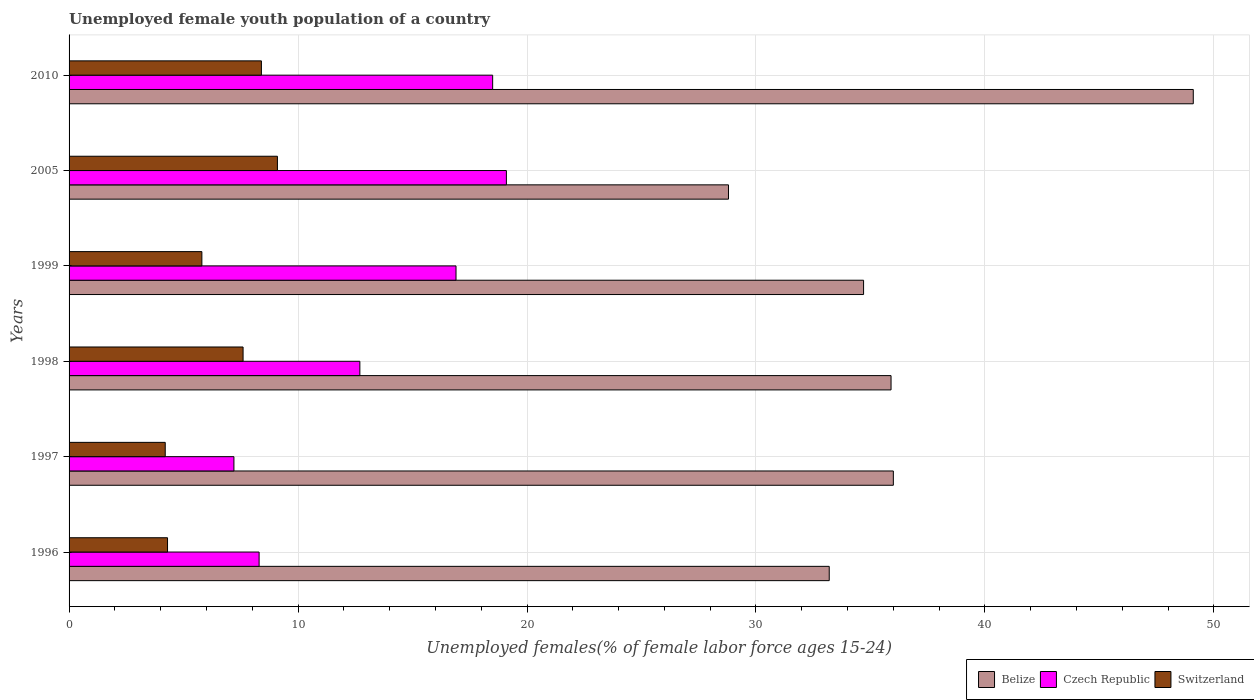How many different coloured bars are there?
Your response must be concise. 3. Are the number of bars per tick equal to the number of legend labels?
Give a very brief answer. Yes. How many bars are there on the 4th tick from the top?
Ensure brevity in your answer.  3. How many bars are there on the 3rd tick from the bottom?
Offer a very short reply. 3. What is the label of the 6th group of bars from the top?
Ensure brevity in your answer.  1996. In how many cases, is the number of bars for a given year not equal to the number of legend labels?
Offer a terse response. 0. What is the percentage of unemployed female youth population in Switzerland in 1999?
Offer a terse response. 5.8. Across all years, what is the maximum percentage of unemployed female youth population in Czech Republic?
Give a very brief answer. 19.1. Across all years, what is the minimum percentage of unemployed female youth population in Czech Republic?
Your response must be concise. 7.2. What is the total percentage of unemployed female youth population in Czech Republic in the graph?
Give a very brief answer. 82.7. What is the difference between the percentage of unemployed female youth population in Switzerland in 1996 and that in 1998?
Provide a short and direct response. -3.3. What is the difference between the percentage of unemployed female youth population in Czech Republic in 2005 and the percentage of unemployed female youth population in Belize in 1999?
Your answer should be compact. -15.6. What is the average percentage of unemployed female youth population in Switzerland per year?
Give a very brief answer. 6.57. In the year 2010, what is the difference between the percentage of unemployed female youth population in Belize and percentage of unemployed female youth population in Czech Republic?
Give a very brief answer. 30.6. What is the ratio of the percentage of unemployed female youth population in Belize in 1999 to that in 2005?
Your answer should be very brief. 1.2. What is the difference between the highest and the second highest percentage of unemployed female youth population in Belize?
Keep it short and to the point. 13.1. What is the difference between the highest and the lowest percentage of unemployed female youth population in Belize?
Ensure brevity in your answer.  20.3. What does the 3rd bar from the top in 2005 represents?
Offer a terse response. Belize. What does the 3rd bar from the bottom in 2005 represents?
Your answer should be compact. Switzerland. Is it the case that in every year, the sum of the percentage of unemployed female youth population in Switzerland and percentage of unemployed female youth population in Belize is greater than the percentage of unemployed female youth population in Czech Republic?
Give a very brief answer. Yes. Are all the bars in the graph horizontal?
Ensure brevity in your answer.  Yes. How many years are there in the graph?
Offer a very short reply. 6. Are the values on the major ticks of X-axis written in scientific E-notation?
Your answer should be very brief. No. Does the graph contain any zero values?
Your response must be concise. No. Does the graph contain grids?
Your response must be concise. Yes. Where does the legend appear in the graph?
Keep it short and to the point. Bottom right. How many legend labels are there?
Offer a terse response. 3. What is the title of the graph?
Ensure brevity in your answer.  Unemployed female youth population of a country. Does "Lao PDR" appear as one of the legend labels in the graph?
Offer a very short reply. No. What is the label or title of the X-axis?
Keep it short and to the point. Unemployed females(% of female labor force ages 15-24). What is the Unemployed females(% of female labor force ages 15-24) in Belize in 1996?
Ensure brevity in your answer.  33.2. What is the Unemployed females(% of female labor force ages 15-24) in Czech Republic in 1996?
Ensure brevity in your answer.  8.3. What is the Unemployed females(% of female labor force ages 15-24) in Switzerland in 1996?
Provide a succinct answer. 4.3. What is the Unemployed females(% of female labor force ages 15-24) of Belize in 1997?
Provide a succinct answer. 36. What is the Unemployed females(% of female labor force ages 15-24) of Czech Republic in 1997?
Your answer should be compact. 7.2. What is the Unemployed females(% of female labor force ages 15-24) in Switzerland in 1997?
Make the answer very short. 4.2. What is the Unemployed females(% of female labor force ages 15-24) in Belize in 1998?
Your response must be concise. 35.9. What is the Unemployed females(% of female labor force ages 15-24) of Czech Republic in 1998?
Your answer should be very brief. 12.7. What is the Unemployed females(% of female labor force ages 15-24) in Switzerland in 1998?
Your answer should be very brief. 7.6. What is the Unemployed females(% of female labor force ages 15-24) in Belize in 1999?
Your answer should be very brief. 34.7. What is the Unemployed females(% of female labor force ages 15-24) in Czech Republic in 1999?
Your response must be concise. 16.9. What is the Unemployed females(% of female labor force ages 15-24) of Switzerland in 1999?
Make the answer very short. 5.8. What is the Unemployed females(% of female labor force ages 15-24) of Belize in 2005?
Provide a short and direct response. 28.8. What is the Unemployed females(% of female labor force ages 15-24) in Czech Republic in 2005?
Your answer should be compact. 19.1. What is the Unemployed females(% of female labor force ages 15-24) of Switzerland in 2005?
Provide a short and direct response. 9.1. What is the Unemployed females(% of female labor force ages 15-24) of Belize in 2010?
Your response must be concise. 49.1. What is the Unemployed females(% of female labor force ages 15-24) in Switzerland in 2010?
Provide a succinct answer. 8.4. Across all years, what is the maximum Unemployed females(% of female labor force ages 15-24) of Belize?
Keep it short and to the point. 49.1. Across all years, what is the maximum Unemployed females(% of female labor force ages 15-24) of Czech Republic?
Your answer should be very brief. 19.1. Across all years, what is the maximum Unemployed females(% of female labor force ages 15-24) in Switzerland?
Give a very brief answer. 9.1. Across all years, what is the minimum Unemployed females(% of female labor force ages 15-24) in Belize?
Provide a succinct answer. 28.8. Across all years, what is the minimum Unemployed females(% of female labor force ages 15-24) of Czech Republic?
Offer a very short reply. 7.2. Across all years, what is the minimum Unemployed females(% of female labor force ages 15-24) in Switzerland?
Provide a short and direct response. 4.2. What is the total Unemployed females(% of female labor force ages 15-24) in Belize in the graph?
Offer a terse response. 217.7. What is the total Unemployed females(% of female labor force ages 15-24) in Czech Republic in the graph?
Your answer should be very brief. 82.7. What is the total Unemployed females(% of female labor force ages 15-24) of Switzerland in the graph?
Ensure brevity in your answer.  39.4. What is the difference between the Unemployed females(% of female labor force ages 15-24) in Belize in 1996 and that in 1997?
Provide a succinct answer. -2.8. What is the difference between the Unemployed females(% of female labor force ages 15-24) of Belize in 1996 and that in 1998?
Offer a very short reply. -2.7. What is the difference between the Unemployed females(% of female labor force ages 15-24) in Belize in 1996 and that in 1999?
Provide a succinct answer. -1.5. What is the difference between the Unemployed females(% of female labor force ages 15-24) of Switzerland in 1996 and that in 1999?
Your answer should be very brief. -1.5. What is the difference between the Unemployed females(% of female labor force ages 15-24) in Belize in 1996 and that in 2005?
Offer a very short reply. 4.4. What is the difference between the Unemployed females(% of female labor force ages 15-24) of Switzerland in 1996 and that in 2005?
Keep it short and to the point. -4.8. What is the difference between the Unemployed females(% of female labor force ages 15-24) of Belize in 1996 and that in 2010?
Give a very brief answer. -15.9. What is the difference between the Unemployed females(% of female labor force ages 15-24) of Switzerland in 1996 and that in 2010?
Give a very brief answer. -4.1. What is the difference between the Unemployed females(% of female labor force ages 15-24) in Switzerland in 1997 and that in 1998?
Your answer should be compact. -3.4. What is the difference between the Unemployed females(% of female labor force ages 15-24) in Belize in 1997 and that in 1999?
Offer a very short reply. 1.3. What is the difference between the Unemployed females(% of female labor force ages 15-24) in Czech Republic in 1997 and that in 1999?
Keep it short and to the point. -9.7. What is the difference between the Unemployed females(% of female labor force ages 15-24) of Czech Republic in 1997 and that in 2005?
Make the answer very short. -11.9. What is the difference between the Unemployed females(% of female labor force ages 15-24) in Czech Republic in 1997 and that in 2010?
Your answer should be very brief. -11.3. What is the difference between the Unemployed females(% of female labor force ages 15-24) in Switzerland in 1997 and that in 2010?
Offer a very short reply. -4.2. What is the difference between the Unemployed females(% of female labor force ages 15-24) in Czech Republic in 1998 and that in 1999?
Provide a succinct answer. -4.2. What is the difference between the Unemployed females(% of female labor force ages 15-24) of Belize in 1998 and that in 2005?
Your answer should be compact. 7.1. What is the difference between the Unemployed females(% of female labor force ages 15-24) of Czech Republic in 1998 and that in 2005?
Your response must be concise. -6.4. What is the difference between the Unemployed females(% of female labor force ages 15-24) in Belize in 1998 and that in 2010?
Ensure brevity in your answer.  -13.2. What is the difference between the Unemployed females(% of female labor force ages 15-24) of Czech Republic in 1998 and that in 2010?
Make the answer very short. -5.8. What is the difference between the Unemployed females(% of female labor force ages 15-24) in Czech Republic in 1999 and that in 2005?
Give a very brief answer. -2.2. What is the difference between the Unemployed females(% of female labor force ages 15-24) in Belize in 1999 and that in 2010?
Offer a very short reply. -14.4. What is the difference between the Unemployed females(% of female labor force ages 15-24) in Switzerland in 1999 and that in 2010?
Provide a short and direct response. -2.6. What is the difference between the Unemployed females(% of female labor force ages 15-24) of Belize in 2005 and that in 2010?
Your answer should be very brief. -20.3. What is the difference between the Unemployed females(% of female labor force ages 15-24) in Czech Republic in 2005 and that in 2010?
Provide a succinct answer. 0.6. What is the difference between the Unemployed females(% of female labor force ages 15-24) of Belize in 1996 and the Unemployed females(% of female labor force ages 15-24) of Czech Republic in 1997?
Provide a succinct answer. 26. What is the difference between the Unemployed females(% of female labor force ages 15-24) in Belize in 1996 and the Unemployed females(% of female labor force ages 15-24) in Switzerland in 1998?
Your answer should be compact. 25.6. What is the difference between the Unemployed females(% of female labor force ages 15-24) in Czech Republic in 1996 and the Unemployed females(% of female labor force ages 15-24) in Switzerland in 1998?
Keep it short and to the point. 0.7. What is the difference between the Unemployed females(% of female labor force ages 15-24) of Belize in 1996 and the Unemployed females(% of female labor force ages 15-24) of Czech Republic in 1999?
Offer a very short reply. 16.3. What is the difference between the Unemployed females(% of female labor force ages 15-24) of Belize in 1996 and the Unemployed females(% of female labor force ages 15-24) of Switzerland in 1999?
Provide a short and direct response. 27.4. What is the difference between the Unemployed females(% of female labor force ages 15-24) in Belize in 1996 and the Unemployed females(% of female labor force ages 15-24) in Switzerland in 2005?
Your answer should be compact. 24.1. What is the difference between the Unemployed females(% of female labor force ages 15-24) in Belize in 1996 and the Unemployed females(% of female labor force ages 15-24) in Czech Republic in 2010?
Give a very brief answer. 14.7. What is the difference between the Unemployed females(% of female labor force ages 15-24) of Belize in 1996 and the Unemployed females(% of female labor force ages 15-24) of Switzerland in 2010?
Your response must be concise. 24.8. What is the difference between the Unemployed females(% of female labor force ages 15-24) of Czech Republic in 1996 and the Unemployed females(% of female labor force ages 15-24) of Switzerland in 2010?
Keep it short and to the point. -0.1. What is the difference between the Unemployed females(% of female labor force ages 15-24) in Belize in 1997 and the Unemployed females(% of female labor force ages 15-24) in Czech Republic in 1998?
Provide a succinct answer. 23.3. What is the difference between the Unemployed females(% of female labor force ages 15-24) of Belize in 1997 and the Unemployed females(% of female labor force ages 15-24) of Switzerland in 1998?
Make the answer very short. 28.4. What is the difference between the Unemployed females(% of female labor force ages 15-24) in Belize in 1997 and the Unemployed females(% of female labor force ages 15-24) in Switzerland in 1999?
Keep it short and to the point. 30.2. What is the difference between the Unemployed females(% of female labor force ages 15-24) in Czech Republic in 1997 and the Unemployed females(% of female labor force ages 15-24) in Switzerland in 1999?
Provide a succinct answer. 1.4. What is the difference between the Unemployed females(% of female labor force ages 15-24) of Belize in 1997 and the Unemployed females(% of female labor force ages 15-24) of Czech Republic in 2005?
Offer a terse response. 16.9. What is the difference between the Unemployed females(% of female labor force ages 15-24) in Belize in 1997 and the Unemployed females(% of female labor force ages 15-24) in Switzerland in 2005?
Offer a terse response. 26.9. What is the difference between the Unemployed females(% of female labor force ages 15-24) of Belize in 1997 and the Unemployed females(% of female labor force ages 15-24) of Czech Republic in 2010?
Offer a terse response. 17.5. What is the difference between the Unemployed females(% of female labor force ages 15-24) of Belize in 1997 and the Unemployed females(% of female labor force ages 15-24) of Switzerland in 2010?
Give a very brief answer. 27.6. What is the difference between the Unemployed females(% of female labor force ages 15-24) in Belize in 1998 and the Unemployed females(% of female labor force ages 15-24) in Czech Republic in 1999?
Your response must be concise. 19. What is the difference between the Unemployed females(% of female labor force ages 15-24) of Belize in 1998 and the Unemployed females(% of female labor force ages 15-24) of Switzerland in 1999?
Offer a terse response. 30.1. What is the difference between the Unemployed females(% of female labor force ages 15-24) in Czech Republic in 1998 and the Unemployed females(% of female labor force ages 15-24) in Switzerland in 1999?
Your answer should be compact. 6.9. What is the difference between the Unemployed females(% of female labor force ages 15-24) in Belize in 1998 and the Unemployed females(% of female labor force ages 15-24) in Czech Republic in 2005?
Make the answer very short. 16.8. What is the difference between the Unemployed females(% of female labor force ages 15-24) of Belize in 1998 and the Unemployed females(% of female labor force ages 15-24) of Switzerland in 2005?
Offer a very short reply. 26.8. What is the difference between the Unemployed females(% of female labor force ages 15-24) of Czech Republic in 1998 and the Unemployed females(% of female labor force ages 15-24) of Switzerland in 2005?
Give a very brief answer. 3.6. What is the difference between the Unemployed females(% of female labor force ages 15-24) in Belize in 1998 and the Unemployed females(% of female labor force ages 15-24) in Switzerland in 2010?
Make the answer very short. 27.5. What is the difference between the Unemployed females(% of female labor force ages 15-24) of Czech Republic in 1998 and the Unemployed females(% of female labor force ages 15-24) of Switzerland in 2010?
Make the answer very short. 4.3. What is the difference between the Unemployed females(% of female labor force ages 15-24) of Belize in 1999 and the Unemployed females(% of female labor force ages 15-24) of Czech Republic in 2005?
Ensure brevity in your answer.  15.6. What is the difference between the Unemployed females(% of female labor force ages 15-24) of Belize in 1999 and the Unemployed females(% of female labor force ages 15-24) of Switzerland in 2005?
Your answer should be compact. 25.6. What is the difference between the Unemployed females(% of female labor force ages 15-24) of Belize in 1999 and the Unemployed females(% of female labor force ages 15-24) of Switzerland in 2010?
Provide a succinct answer. 26.3. What is the difference between the Unemployed females(% of female labor force ages 15-24) in Czech Republic in 1999 and the Unemployed females(% of female labor force ages 15-24) in Switzerland in 2010?
Provide a succinct answer. 8.5. What is the difference between the Unemployed females(% of female labor force ages 15-24) of Belize in 2005 and the Unemployed females(% of female labor force ages 15-24) of Switzerland in 2010?
Give a very brief answer. 20.4. What is the difference between the Unemployed females(% of female labor force ages 15-24) in Czech Republic in 2005 and the Unemployed females(% of female labor force ages 15-24) in Switzerland in 2010?
Offer a very short reply. 10.7. What is the average Unemployed females(% of female labor force ages 15-24) in Belize per year?
Keep it short and to the point. 36.28. What is the average Unemployed females(% of female labor force ages 15-24) in Czech Republic per year?
Your response must be concise. 13.78. What is the average Unemployed females(% of female labor force ages 15-24) of Switzerland per year?
Your answer should be compact. 6.57. In the year 1996, what is the difference between the Unemployed females(% of female labor force ages 15-24) of Belize and Unemployed females(% of female labor force ages 15-24) of Czech Republic?
Offer a terse response. 24.9. In the year 1996, what is the difference between the Unemployed females(% of female labor force ages 15-24) in Belize and Unemployed females(% of female labor force ages 15-24) in Switzerland?
Provide a succinct answer. 28.9. In the year 1997, what is the difference between the Unemployed females(% of female labor force ages 15-24) of Belize and Unemployed females(% of female labor force ages 15-24) of Czech Republic?
Offer a very short reply. 28.8. In the year 1997, what is the difference between the Unemployed females(% of female labor force ages 15-24) in Belize and Unemployed females(% of female labor force ages 15-24) in Switzerland?
Your answer should be compact. 31.8. In the year 1998, what is the difference between the Unemployed females(% of female labor force ages 15-24) in Belize and Unemployed females(% of female labor force ages 15-24) in Czech Republic?
Your response must be concise. 23.2. In the year 1998, what is the difference between the Unemployed females(% of female labor force ages 15-24) in Belize and Unemployed females(% of female labor force ages 15-24) in Switzerland?
Offer a terse response. 28.3. In the year 1998, what is the difference between the Unemployed females(% of female labor force ages 15-24) in Czech Republic and Unemployed females(% of female labor force ages 15-24) in Switzerland?
Make the answer very short. 5.1. In the year 1999, what is the difference between the Unemployed females(% of female labor force ages 15-24) of Belize and Unemployed females(% of female labor force ages 15-24) of Czech Republic?
Your answer should be compact. 17.8. In the year 1999, what is the difference between the Unemployed females(% of female labor force ages 15-24) of Belize and Unemployed females(% of female labor force ages 15-24) of Switzerland?
Your answer should be compact. 28.9. In the year 1999, what is the difference between the Unemployed females(% of female labor force ages 15-24) in Czech Republic and Unemployed females(% of female labor force ages 15-24) in Switzerland?
Give a very brief answer. 11.1. In the year 2005, what is the difference between the Unemployed females(% of female labor force ages 15-24) of Belize and Unemployed females(% of female labor force ages 15-24) of Czech Republic?
Offer a terse response. 9.7. In the year 2005, what is the difference between the Unemployed females(% of female labor force ages 15-24) in Czech Republic and Unemployed females(% of female labor force ages 15-24) in Switzerland?
Your answer should be compact. 10. In the year 2010, what is the difference between the Unemployed females(% of female labor force ages 15-24) of Belize and Unemployed females(% of female labor force ages 15-24) of Czech Republic?
Offer a very short reply. 30.6. In the year 2010, what is the difference between the Unemployed females(% of female labor force ages 15-24) of Belize and Unemployed females(% of female labor force ages 15-24) of Switzerland?
Provide a short and direct response. 40.7. In the year 2010, what is the difference between the Unemployed females(% of female labor force ages 15-24) in Czech Republic and Unemployed females(% of female labor force ages 15-24) in Switzerland?
Your response must be concise. 10.1. What is the ratio of the Unemployed females(% of female labor force ages 15-24) in Belize in 1996 to that in 1997?
Provide a succinct answer. 0.92. What is the ratio of the Unemployed females(% of female labor force ages 15-24) of Czech Republic in 1996 to that in 1997?
Your answer should be very brief. 1.15. What is the ratio of the Unemployed females(% of female labor force ages 15-24) of Switzerland in 1996 to that in 1997?
Make the answer very short. 1.02. What is the ratio of the Unemployed females(% of female labor force ages 15-24) of Belize in 1996 to that in 1998?
Offer a terse response. 0.92. What is the ratio of the Unemployed females(% of female labor force ages 15-24) of Czech Republic in 1996 to that in 1998?
Provide a succinct answer. 0.65. What is the ratio of the Unemployed females(% of female labor force ages 15-24) of Switzerland in 1996 to that in 1998?
Give a very brief answer. 0.57. What is the ratio of the Unemployed females(% of female labor force ages 15-24) of Belize in 1996 to that in 1999?
Provide a short and direct response. 0.96. What is the ratio of the Unemployed females(% of female labor force ages 15-24) in Czech Republic in 1996 to that in 1999?
Your answer should be compact. 0.49. What is the ratio of the Unemployed females(% of female labor force ages 15-24) of Switzerland in 1996 to that in 1999?
Make the answer very short. 0.74. What is the ratio of the Unemployed females(% of female labor force ages 15-24) in Belize in 1996 to that in 2005?
Your response must be concise. 1.15. What is the ratio of the Unemployed females(% of female labor force ages 15-24) of Czech Republic in 1996 to that in 2005?
Your answer should be compact. 0.43. What is the ratio of the Unemployed females(% of female labor force ages 15-24) of Switzerland in 1996 to that in 2005?
Give a very brief answer. 0.47. What is the ratio of the Unemployed females(% of female labor force ages 15-24) of Belize in 1996 to that in 2010?
Provide a succinct answer. 0.68. What is the ratio of the Unemployed females(% of female labor force ages 15-24) of Czech Republic in 1996 to that in 2010?
Provide a short and direct response. 0.45. What is the ratio of the Unemployed females(% of female labor force ages 15-24) in Switzerland in 1996 to that in 2010?
Your answer should be compact. 0.51. What is the ratio of the Unemployed females(% of female labor force ages 15-24) in Belize in 1997 to that in 1998?
Keep it short and to the point. 1. What is the ratio of the Unemployed females(% of female labor force ages 15-24) in Czech Republic in 1997 to that in 1998?
Keep it short and to the point. 0.57. What is the ratio of the Unemployed females(% of female labor force ages 15-24) in Switzerland in 1997 to that in 1998?
Ensure brevity in your answer.  0.55. What is the ratio of the Unemployed females(% of female labor force ages 15-24) in Belize in 1997 to that in 1999?
Give a very brief answer. 1.04. What is the ratio of the Unemployed females(% of female labor force ages 15-24) of Czech Republic in 1997 to that in 1999?
Provide a short and direct response. 0.43. What is the ratio of the Unemployed females(% of female labor force ages 15-24) in Switzerland in 1997 to that in 1999?
Provide a succinct answer. 0.72. What is the ratio of the Unemployed females(% of female labor force ages 15-24) of Belize in 1997 to that in 2005?
Ensure brevity in your answer.  1.25. What is the ratio of the Unemployed females(% of female labor force ages 15-24) of Czech Republic in 1997 to that in 2005?
Make the answer very short. 0.38. What is the ratio of the Unemployed females(% of female labor force ages 15-24) in Switzerland in 1997 to that in 2005?
Your response must be concise. 0.46. What is the ratio of the Unemployed females(% of female labor force ages 15-24) in Belize in 1997 to that in 2010?
Provide a succinct answer. 0.73. What is the ratio of the Unemployed females(% of female labor force ages 15-24) in Czech Republic in 1997 to that in 2010?
Your answer should be compact. 0.39. What is the ratio of the Unemployed females(% of female labor force ages 15-24) in Switzerland in 1997 to that in 2010?
Keep it short and to the point. 0.5. What is the ratio of the Unemployed females(% of female labor force ages 15-24) in Belize in 1998 to that in 1999?
Give a very brief answer. 1.03. What is the ratio of the Unemployed females(% of female labor force ages 15-24) of Czech Republic in 1998 to that in 1999?
Provide a short and direct response. 0.75. What is the ratio of the Unemployed females(% of female labor force ages 15-24) of Switzerland in 1998 to that in 1999?
Give a very brief answer. 1.31. What is the ratio of the Unemployed females(% of female labor force ages 15-24) of Belize in 1998 to that in 2005?
Provide a short and direct response. 1.25. What is the ratio of the Unemployed females(% of female labor force ages 15-24) in Czech Republic in 1998 to that in 2005?
Your answer should be compact. 0.66. What is the ratio of the Unemployed females(% of female labor force ages 15-24) in Switzerland in 1998 to that in 2005?
Give a very brief answer. 0.84. What is the ratio of the Unemployed females(% of female labor force ages 15-24) of Belize in 1998 to that in 2010?
Your answer should be very brief. 0.73. What is the ratio of the Unemployed females(% of female labor force ages 15-24) in Czech Republic in 1998 to that in 2010?
Offer a very short reply. 0.69. What is the ratio of the Unemployed females(% of female labor force ages 15-24) in Switzerland in 1998 to that in 2010?
Offer a terse response. 0.9. What is the ratio of the Unemployed females(% of female labor force ages 15-24) of Belize in 1999 to that in 2005?
Provide a short and direct response. 1.2. What is the ratio of the Unemployed females(% of female labor force ages 15-24) of Czech Republic in 1999 to that in 2005?
Make the answer very short. 0.88. What is the ratio of the Unemployed females(% of female labor force ages 15-24) in Switzerland in 1999 to that in 2005?
Your response must be concise. 0.64. What is the ratio of the Unemployed females(% of female labor force ages 15-24) in Belize in 1999 to that in 2010?
Your response must be concise. 0.71. What is the ratio of the Unemployed females(% of female labor force ages 15-24) in Czech Republic in 1999 to that in 2010?
Ensure brevity in your answer.  0.91. What is the ratio of the Unemployed females(% of female labor force ages 15-24) in Switzerland in 1999 to that in 2010?
Your response must be concise. 0.69. What is the ratio of the Unemployed females(% of female labor force ages 15-24) of Belize in 2005 to that in 2010?
Offer a very short reply. 0.59. What is the ratio of the Unemployed females(% of female labor force ages 15-24) in Czech Republic in 2005 to that in 2010?
Offer a very short reply. 1.03. What is the ratio of the Unemployed females(% of female labor force ages 15-24) of Switzerland in 2005 to that in 2010?
Offer a terse response. 1.08. What is the difference between the highest and the lowest Unemployed females(% of female labor force ages 15-24) in Belize?
Provide a short and direct response. 20.3. What is the difference between the highest and the lowest Unemployed females(% of female labor force ages 15-24) in Czech Republic?
Offer a terse response. 11.9. 